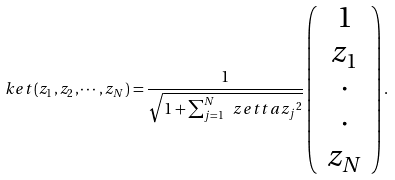<formula> <loc_0><loc_0><loc_500><loc_500>\ k e t { \left ( z _ { 1 } , z _ { 2 } , \cdots , z _ { N } \right ) } = \frac { 1 } { \sqrt { 1 + \sum _ { j = 1 } ^ { N } \ z e t t a { z _ { j } } ^ { 2 } } } \left ( \begin{array} { c } 1 \\ z _ { 1 } \\ \cdot \\ \cdot \\ z _ { N } \end{array} \right ) . \\</formula> 